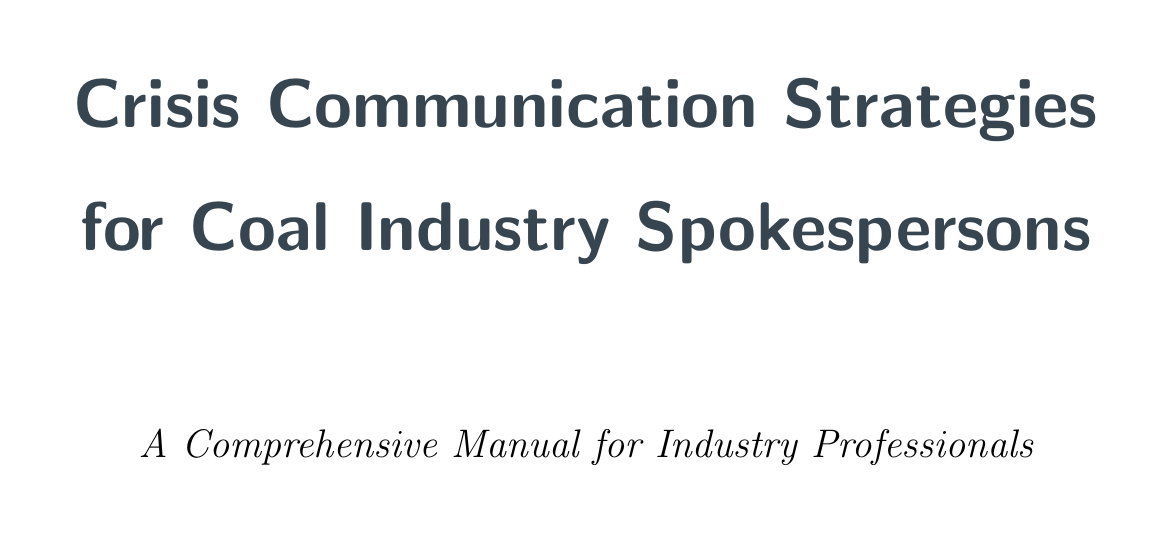what percentage of global electricity generation does coal provide? The document states that coal provides 38% of global electricity generation.
Answer: 38% what is one of the economic benefits of coal mentioned? The document lists job creation in mining regions as one of the economic benefits of coal.
Answer: Job creation what are two environmental concerns related to coal? The document lists CO2 emissions and air pollution as two environmental concerns.
Answer: CO2 emissions and air pollution what technology is mentioned that helps reduce emissions in coal-fired plants? The document mentions carbon capture and storage (CCS) technologies as a way to reduce emissions.
Answer: Carbon capture and storage how does coal contribute to energy security? The document emphasizes domestic availability of coal reserves as a contribution to energy security.
Answer: Domestic availability of coal reserves what is a common criticism of renewable energy sources according to the document? The document highlights intermittency issues with solar and wind power as a common criticism.
Answer: Intermittency issues what is a key tactic for responding to environmental incidents? The document suggests immediate acknowledgment of the issue as a key tactic.
Answer: Immediate acknowledgment which case study focuses on a mining disaster? The document mentions Massey Energy's response to the Upper Big Branch Mine Disaster as a relevant case study.
Answer: Massey Energy's response what is one of the appendices titled? The document includes an appendix titled "Key Industry Organizations and Resources."
Answer: Key Industry Organizations and Resources 